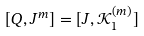<formula> <loc_0><loc_0><loc_500><loc_500>[ Q , J ^ { m } ] = [ J , \mathcal { K } _ { 1 } ^ { ( m ) } ]</formula> 